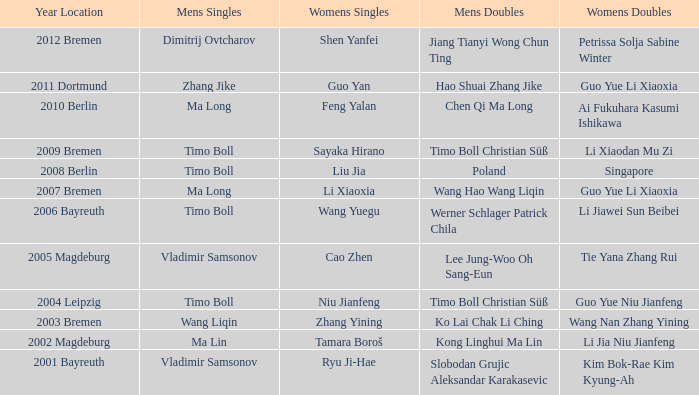Who achieved success in women's singles in the year ma lin dominated in men's singles? Tamara Boroš. 